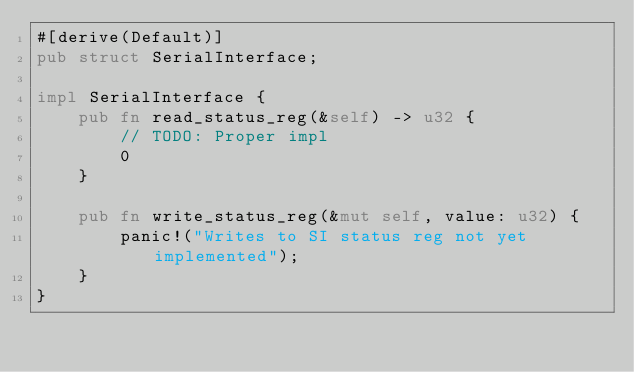<code> <loc_0><loc_0><loc_500><loc_500><_Rust_>#[derive(Default)]
pub struct SerialInterface;

impl SerialInterface {
    pub fn read_status_reg(&self) -> u32 {
        // TODO: Proper impl
        0
    }

    pub fn write_status_reg(&mut self, value: u32) {
        panic!("Writes to SI status reg not yet implemented");
    }
}
</code> 